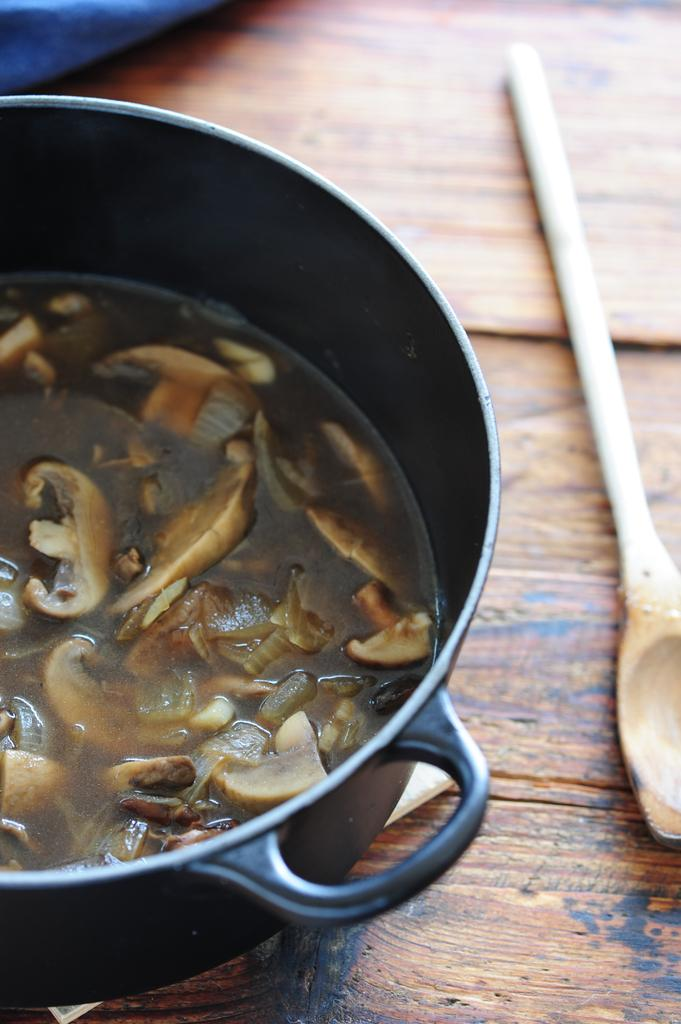What is in the bowl that is visible in the image? There is food in a bowl in the image. What utensil is placed beside the bowl in the image? There is a spoon beside the bowl in the image. Can you see any machines in the image? There are no machines visible in the image. How many apples are in the bowl in the image? The image does not specify the type of food in the bowl, so it is impossible to determine if there are any apples present. 